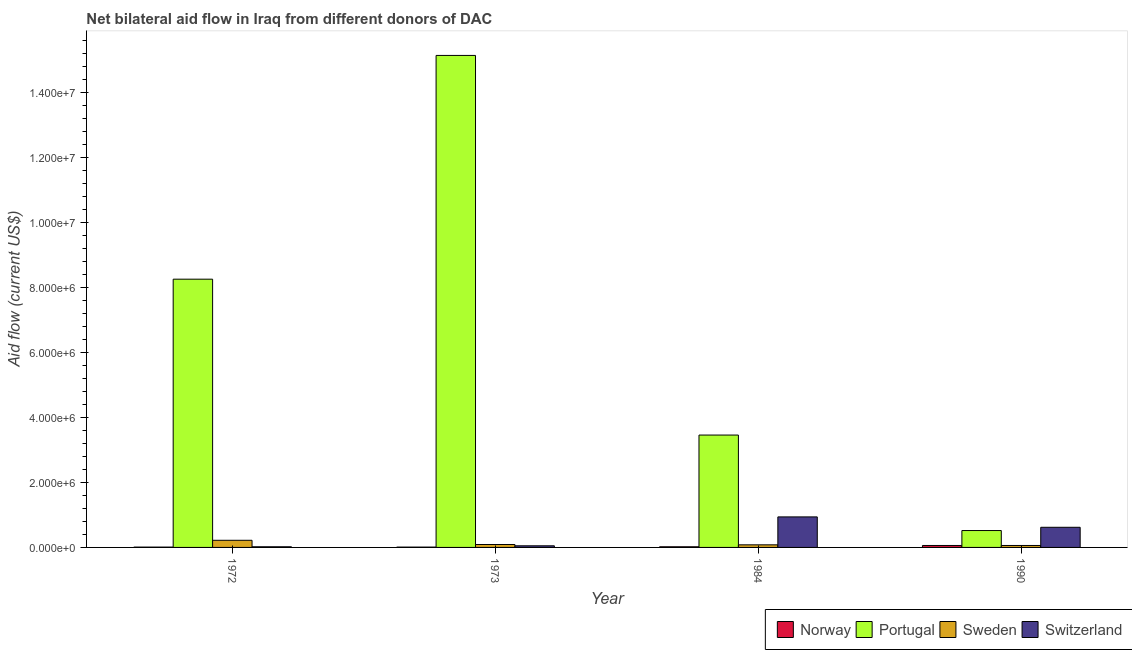How many different coloured bars are there?
Keep it short and to the point. 4. Are the number of bars on each tick of the X-axis equal?
Your response must be concise. Yes. How many bars are there on the 4th tick from the left?
Ensure brevity in your answer.  4. What is the label of the 3rd group of bars from the left?
Your response must be concise. 1984. In how many cases, is the number of bars for a given year not equal to the number of legend labels?
Provide a succinct answer. 0. What is the amount of aid given by portugal in 1990?
Give a very brief answer. 5.20e+05. Across all years, what is the maximum amount of aid given by sweden?
Your answer should be very brief. 2.20e+05. Across all years, what is the minimum amount of aid given by switzerland?
Your response must be concise. 2.00e+04. In which year was the amount of aid given by switzerland minimum?
Your response must be concise. 1972. What is the total amount of aid given by sweden in the graph?
Your answer should be compact. 4.50e+05. What is the difference between the amount of aid given by norway in 1973 and that in 1984?
Keep it short and to the point. -10000. What is the difference between the amount of aid given by sweden in 1972 and the amount of aid given by norway in 1984?
Your answer should be compact. 1.40e+05. What is the average amount of aid given by switzerland per year?
Ensure brevity in your answer.  4.08e+05. In the year 1984, what is the difference between the amount of aid given by sweden and amount of aid given by norway?
Make the answer very short. 0. In how many years, is the amount of aid given by switzerland greater than 2800000 US$?
Your answer should be compact. 0. What is the ratio of the amount of aid given by switzerland in 1973 to that in 1984?
Your answer should be very brief. 0.05. Is the amount of aid given by switzerland in 1972 less than that in 1990?
Ensure brevity in your answer.  Yes. Is the difference between the amount of aid given by portugal in 1972 and 1990 greater than the difference between the amount of aid given by norway in 1972 and 1990?
Ensure brevity in your answer.  No. What is the difference between the highest and the second highest amount of aid given by portugal?
Give a very brief answer. 6.89e+06. What is the difference between the highest and the lowest amount of aid given by portugal?
Your response must be concise. 1.46e+07. In how many years, is the amount of aid given by portugal greater than the average amount of aid given by portugal taken over all years?
Keep it short and to the point. 2. Is the sum of the amount of aid given by switzerland in 1972 and 1973 greater than the maximum amount of aid given by norway across all years?
Keep it short and to the point. No. What does the 4th bar from the left in 1990 represents?
Your answer should be compact. Switzerland. What does the 3rd bar from the right in 1990 represents?
Offer a terse response. Portugal. Is it the case that in every year, the sum of the amount of aid given by norway and amount of aid given by portugal is greater than the amount of aid given by sweden?
Provide a short and direct response. Yes. How many years are there in the graph?
Your response must be concise. 4. What is the difference between two consecutive major ticks on the Y-axis?
Give a very brief answer. 2.00e+06. Does the graph contain grids?
Provide a short and direct response. No. Where does the legend appear in the graph?
Your answer should be compact. Bottom right. What is the title of the graph?
Your answer should be compact. Net bilateral aid flow in Iraq from different donors of DAC. Does "Norway" appear as one of the legend labels in the graph?
Keep it short and to the point. Yes. What is the label or title of the Y-axis?
Make the answer very short. Aid flow (current US$). What is the Aid flow (current US$) of Norway in 1972?
Provide a succinct answer. 10000. What is the Aid flow (current US$) of Portugal in 1972?
Your answer should be very brief. 8.26e+06. What is the Aid flow (current US$) of Sweden in 1972?
Provide a short and direct response. 2.20e+05. What is the Aid flow (current US$) in Switzerland in 1972?
Your answer should be very brief. 2.00e+04. What is the Aid flow (current US$) of Portugal in 1973?
Offer a terse response. 1.52e+07. What is the Aid flow (current US$) in Sweden in 1973?
Your response must be concise. 9.00e+04. What is the Aid flow (current US$) of Switzerland in 1973?
Ensure brevity in your answer.  5.00e+04. What is the Aid flow (current US$) in Norway in 1984?
Your answer should be compact. 2.00e+04. What is the Aid flow (current US$) in Portugal in 1984?
Offer a terse response. 3.46e+06. What is the Aid flow (current US$) in Switzerland in 1984?
Provide a short and direct response. 9.40e+05. What is the Aid flow (current US$) in Norway in 1990?
Give a very brief answer. 6.00e+04. What is the Aid flow (current US$) of Portugal in 1990?
Offer a terse response. 5.20e+05. What is the Aid flow (current US$) of Switzerland in 1990?
Your answer should be very brief. 6.20e+05. Across all years, what is the maximum Aid flow (current US$) in Portugal?
Provide a succinct answer. 1.52e+07. Across all years, what is the maximum Aid flow (current US$) in Switzerland?
Make the answer very short. 9.40e+05. Across all years, what is the minimum Aid flow (current US$) in Norway?
Your answer should be compact. 10000. Across all years, what is the minimum Aid flow (current US$) in Portugal?
Make the answer very short. 5.20e+05. Across all years, what is the minimum Aid flow (current US$) in Switzerland?
Give a very brief answer. 2.00e+04. What is the total Aid flow (current US$) in Portugal in the graph?
Offer a terse response. 2.74e+07. What is the total Aid flow (current US$) in Switzerland in the graph?
Your answer should be very brief. 1.63e+06. What is the difference between the Aid flow (current US$) in Portugal in 1972 and that in 1973?
Provide a short and direct response. -6.89e+06. What is the difference between the Aid flow (current US$) in Sweden in 1972 and that in 1973?
Ensure brevity in your answer.  1.30e+05. What is the difference between the Aid flow (current US$) of Switzerland in 1972 and that in 1973?
Your response must be concise. -3.00e+04. What is the difference between the Aid flow (current US$) in Portugal in 1972 and that in 1984?
Offer a very short reply. 4.80e+06. What is the difference between the Aid flow (current US$) of Switzerland in 1972 and that in 1984?
Ensure brevity in your answer.  -9.20e+05. What is the difference between the Aid flow (current US$) of Norway in 1972 and that in 1990?
Offer a very short reply. -5.00e+04. What is the difference between the Aid flow (current US$) in Portugal in 1972 and that in 1990?
Make the answer very short. 7.74e+06. What is the difference between the Aid flow (current US$) of Switzerland in 1972 and that in 1990?
Give a very brief answer. -6.00e+05. What is the difference between the Aid flow (current US$) of Portugal in 1973 and that in 1984?
Provide a short and direct response. 1.17e+07. What is the difference between the Aid flow (current US$) of Switzerland in 1973 and that in 1984?
Ensure brevity in your answer.  -8.90e+05. What is the difference between the Aid flow (current US$) of Portugal in 1973 and that in 1990?
Give a very brief answer. 1.46e+07. What is the difference between the Aid flow (current US$) of Sweden in 1973 and that in 1990?
Keep it short and to the point. 3.00e+04. What is the difference between the Aid flow (current US$) in Switzerland in 1973 and that in 1990?
Give a very brief answer. -5.70e+05. What is the difference between the Aid flow (current US$) of Norway in 1984 and that in 1990?
Make the answer very short. -4.00e+04. What is the difference between the Aid flow (current US$) in Portugal in 1984 and that in 1990?
Your response must be concise. 2.94e+06. What is the difference between the Aid flow (current US$) of Switzerland in 1984 and that in 1990?
Give a very brief answer. 3.20e+05. What is the difference between the Aid flow (current US$) of Norway in 1972 and the Aid flow (current US$) of Portugal in 1973?
Offer a terse response. -1.51e+07. What is the difference between the Aid flow (current US$) of Portugal in 1972 and the Aid flow (current US$) of Sweden in 1973?
Your response must be concise. 8.17e+06. What is the difference between the Aid flow (current US$) in Portugal in 1972 and the Aid flow (current US$) in Switzerland in 1973?
Ensure brevity in your answer.  8.21e+06. What is the difference between the Aid flow (current US$) of Norway in 1972 and the Aid flow (current US$) of Portugal in 1984?
Keep it short and to the point. -3.45e+06. What is the difference between the Aid flow (current US$) of Norway in 1972 and the Aid flow (current US$) of Switzerland in 1984?
Provide a short and direct response. -9.30e+05. What is the difference between the Aid flow (current US$) in Portugal in 1972 and the Aid flow (current US$) in Sweden in 1984?
Your answer should be compact. 8.18e+06. What is the difference between the Aid flow (current US$) of Portugal in 1972 and the Aid flow (current US$) of Switzerland in 1984?
Offer a terse response. 7.32e+06. What is the difference between the Aid flow (current US$) of Sweden in 1972 and the Aid flow (current US$) of Switzerland in 1984?
Keep it short and to the point. -7.20e+05. What is the difference between the Aid flow (current US$) of Norway in 1972 and the Aid flow (current US$) of Portugal in 1990?
Your answer should be very brief. -5.10e+05. What is the difference between the Aid flow (current US$) of Norway in 1972 and the Aid flow (current US$) of Switzerland in 1990?
Keep it short and to the point. -6.10e+05. What is the difference between the Aid flow (current US$) in Portugal in 1972 and the Aid flow (current US$) in Sweden in 1990?
Provide a succinct answer. 8.20e+06. What is the difference between the Aid flow (current US$) of Portugal in 1972 and the Aid flow (current US$) of Switzerland in 1990?
Provide a succinct answer. 7.64e+06. What is the difference between the Aid flow (current US$) of Sweden in 1972 and the Aid flow (current US$) of Switzerland in 1990?
Provide a short and direct response. -4.00e+05. What is the difference between the Aid flow (current US$) in Norway in 1973 and the Aid flow (current US$) in Portugal in 1984?
Your answer should be compact. -3.45e+06. What is the difference between the Aid flow (current US$) in Norway in 1973 and the Aid flow (current US$) in Sweden in 1984?
Your answer should be very brief. -7.00e+04. What is the difference between the Aid flow (current US$) in Norway in 1973 and the Aid flow (current US$) in Switzerland in 1984?
Make the answer very short. -9.30e+05. What is the difference between the Aid flow (current US$) in Portugal in 1973 and the Aid flow (current US$) in Sweden in 1984?
Your answer should be very brief. 1.51e+07. What is the difference between the Aid flow (current US$) in Portugal in 1973 and the Aid flow (current US$) in Switzerland in 1984?
Provide a short and direct response. 1.42e+07. What is the difference between the Aid flow (current US$) in Sweden in 1973 and the Aid flow (current US$) in Switzerland in 1984?
Give a very brief answer. -8.50e+05. What is the difference between the Aid flow (current US$) in Norway in 1973 and the Aid flow (current US$) in Portugal in 1990?
Offer a very short reply. -5.10e+05. What is the difference between the Aid flow (current US$) of Norway in 1973 and the Aid flow (current US$) of Sweden in 1990?
Your answer should be compact. -5.00e+04. What is the difference between the Aid flow (current US$) of Norway in 1973 and the Aid flow (current US$) of Switzerland in 1990?
Keep it short and to the point. -6.10e+05. What is the difference between the Aid flow (current US$) in Portugal in 1973 and the Aid flow (current US$) in Sweden in 1990?
Offer a very short reply. 1.51e+07. What is the difference between the Aid flow (current US$) in Portugal in 1973 and the Aid flow (current US$) in Switzerland in 1990?
Make the answer very short. 1.45e+07. What is the difference between the Aid flow (current US$) in Sweden in 1973 and the Aid flow (current US$) in Switzerland in 1990?
Your answer should be compact. -5.30e+05. What is the difference between the Aid flow (current US$) of Norway in 1984 and the Aid flow (current US$) of Portugal in 1990?
Give a very brief answer. -5.00e+05. What is the difference between the Aid flow (current US$) of Norway in 1984 and the Aid flow (current US$) of Sweden in 1990?
Offer a terse response. -4.00e+04. What is the difference between the Aid flow (current US$) in Norway in 1984 and the Aid flow (current US$) in Switzerland in 1990?
Your answer should be compact. -6.00e+05. What is the difference between the Aid flow (current US$) of Portugal in 1984 and the Aid flow (current US$) of Sweden in 1990?
Offer a very short reply. 3.40e+06. What is the difference between the Aid flow (current US$) in Portugal in 1984 and the Aid flow (current US$) in Switzerland in 1990?
Offer a very short reply. 2.84e+06. What is the difference between the Aid flow (current US$) in Sweden in 1984 and the Aid flow (current US$) in Switzerland in 1990?
Make the answer very short. -5.40e+05. What is the average Aid flow (current US$) in Norway per year?
Provide a short and direct response. 2.50e+04. What is the average Aid flow (current US$) of Portugal per year?
Give a very brief answer. 6.85e+06. What is the average Aid flow (current US$) of Sweden per year?
Ensure brevity in your answer.  1.12e+05. What is the average Aid flow (current US$) in Switzerland per year?
Give a very brief answer. 4.08e+05. In the year 1972, what is the difference between the Aid flow (current US$) in Norway and Aid flow (current US$) in Portugal?
Ensure brevity in your answer.  -8.25e+06. In the year 1972, what is the difference between the Aid flow (current US$) in Portugal and Aid flow (current US$) in Sweden?
Keep it short and to the point. 8.04e+06. In the year 1972, what is the difference between the Aid flow (current US$) of Portugal and Aid flow (current US$) of Switzerland?
Offer a terse response. 8.24e+06. In the year 1972, what is the difference between the Aid flow (current US$) of Sweden and Aid flow (current US$) of Switzerland?
Offer a terse response. 2.00e+05. In the year 1973, what is the difference between the Aid flow (current US$) in Norway and Aid flow (current US$) in Portugal?
Provide a short and direct response. -1.51e+07. In the year 1973, what is the difference between the Aid flow (current US$) in Norway and Aid flow (current US$) in Switzerland?
Your answer should be very brief. -4.00e+04. In the year 1973, what is the difference between the Aid flow (current US$) of Portugal and Aid flow (current US$) of Sweden?
Provide a succinct answer. 1.51e+07. In the year 1973, what is the difference between the Aid flow (current US$) of Portugal and Aid flow (current US$) of Switzerland?
Keep it short and to the point. 1.51e+07. In the year 1973, what is the difference between the Aid flow (current US$) in Sweden and Aid flow (current US$) in Switzerland?
Ensure brevity in your answer.  4.00e+04. In the year 1984, what is the difference between the Aid flow (current US$) in Norway and Aid flow (current US$) in Portugal?
Provide a short and direct response. -3.44e+06. In the year 1984, what is the difference between the Aid flow (current US$) in Norway and Aid flow (current US$) in Switzerland?
Your answer should be very brief. -9.20e+05. In the year 1984, what is the difference between the Aid flow (current US$) in Portugal and Aid flow (current US$) in Sweden?
Your answer should be compact. 3.38e+06. In the year 1984, what is the difference between the Aid flow (current US$) in Portugal and Aid flow (current US$) in Switzerland?
Ensure brevity in your answer.  2.52e+06. In the year 1984, what is the difference between the Aid flow (current US$) of Sweden and Aid flow (current US$) of Switzerland?
Your answer should be compact. -8.60e+05. In the year 1990, what is the difference between the Aid flow (current US$) in Norway and Aid flow (current US$) in Portugal?
Provide a succinct answer. -4.60e+05. In the year 1990, what is the difference between the Aid flow (current US$) in Norway and Aid flow (current US$) in Switzerland?
Ensure brevity in your answer.  -5.60e+05. In the year 1990, what is the difference between the Aid flow (current US$) in Portugal and Aid flow (current US$) in Switzerland?
Your answer should be very brief. -1.00e+05. In the year 1990, what is the difference between the Aid flow (current US$) in Sweden and Aid flow (current US$) in Switzerland?
Ensure brevity in your answer.  -5.60e+05. What is the ratio of the Aid flow (current US$) in Portugal in 1972 to that in 1973?
Give a very brief answer. 0.55. What is the ratio of the Aid flow (current US$) of Sweden in 1972 to that in 1973?
Make the answer very short. 2.44. What is the ratio of the Aid flow (current US$) in Switzerland in 1972 to that in 1973?
Give a very brief answer. 0.4. What is the ratio of the Aid flow (current US$) in Portugal in 1972 to that in 1984?
Your answer should be compact. 2.39. What is the ratio of the Aid flow (current US$) of Sweden in 1972 to that in 1984?
Make the answer very short. 2.75. What is the ratio of the Aid flow (current US$) of Switzerland in 1972 to that in 1984?
Your response must be concise. 0.02. What is the ratio of the Aid flow (current US$) in Norway in 1972 to that in 1990?
Your response must be concise. 0.17. What is the ratio of the Aid flow (current US$) of Portugal in 1972 to that in 1990?
Give a very brief answer. 15.88. What is the ratio of the Aid flow (current US$) in Sweden in 1972 to that in 1990?
Offer a terse response. 3.67. What is the ratio of the Aid flow (current US$) of Switzerland in 1972 to that in 1990?
Provide a succinct answer. 0.03. What is the ratio of the Aid flow (current US$) in Portugal in 1973 to that in 1984?
Offer a very short reply. 4.38. What is the ratio of the Aid flow (current US$) in Sweden in 1973 to that in 1984?
Offer a very short reply. 1.12. What is the ratio of the Aid flow (current US$) of Switzerland in 1973 to that in 1984?
Offer a very short reply. 0.05. What is the ratio of the Aid flow (current US$) of Portugal in 1973 to that in 1990?
Provide a succinct answer. 29.13. What is the ratio of the Aid flow (current US$) of Switzerland in 1973 to that in 1990?
Your response must be concise. 0.08. What is the ratio of the Aid flow (current US$) in Portugal in 1984 to that in 1990?
Provide a short and direct response. 6.65. What is the ratio of the Aid flow (current US$) in Switzerland in 1984 to that in 1990?
Provide a short and direct response. 1.52. What is the difference between the highest and the second highest Aid flow (current US$) in Norway?
Keep it short and to the point. 4.00e+04. What is the difference between the highest and the second highest Aid flow (current US$) in Portugal?
Keep it short and to the point. 6.89e+06. What is the difference between the highest and the lowest Aid flow (current US$) of Portugal?
Your answer should be very brief. 1.46e+07. What is the difference between the highest and the lowest Aid flow (current US$) of Switzerland?
Keep it short and to the point. 9.20e+05. 